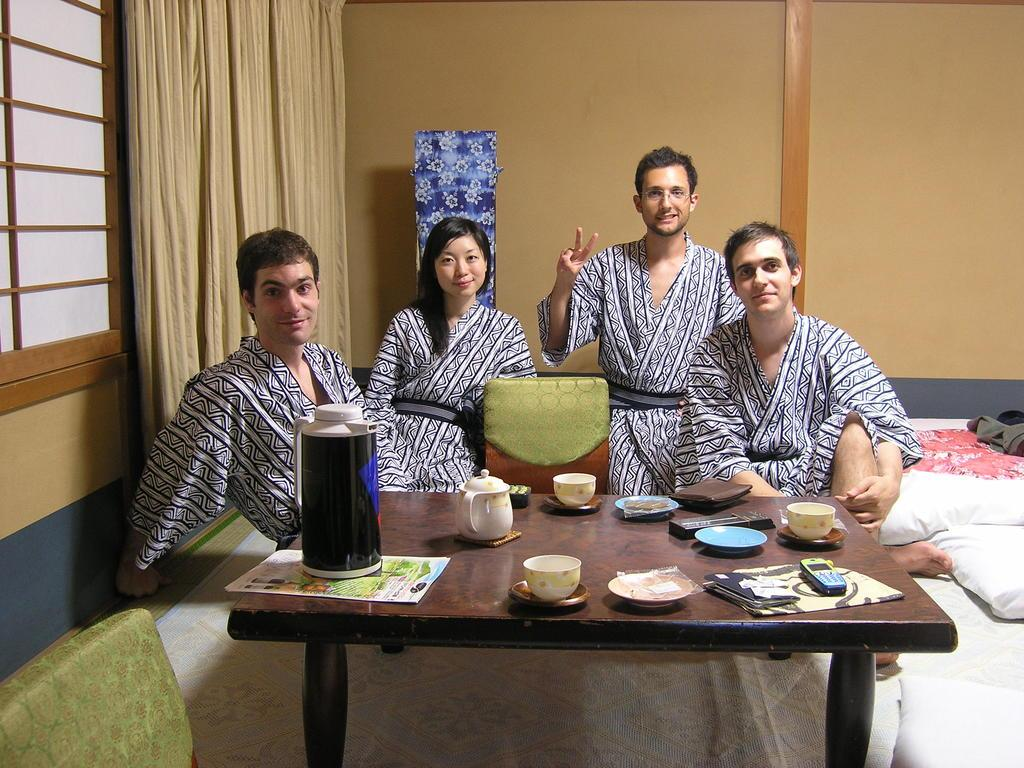What can be seen in the window in the image? There is a window with a curtain in the image. What are the persons in the image doing? The persons in the image are sitting on chairs. What is on the table in the image? The table has a tea pot, a cup, a wallet, a mobile, a plate, and papers on it. What is on the bed in the image? There is a pillow on a bed in the image. What type of skirt is draped over the chair in the image? There is no skirt present in the image; the persons are sitting on chairs without any visible clothing items draped over them. How many snakes are slithering on the table in the image? There are no snakes present in the image; the table has a tea pot, a cup, a wallet, a mobile, a plate, and papers on it. 